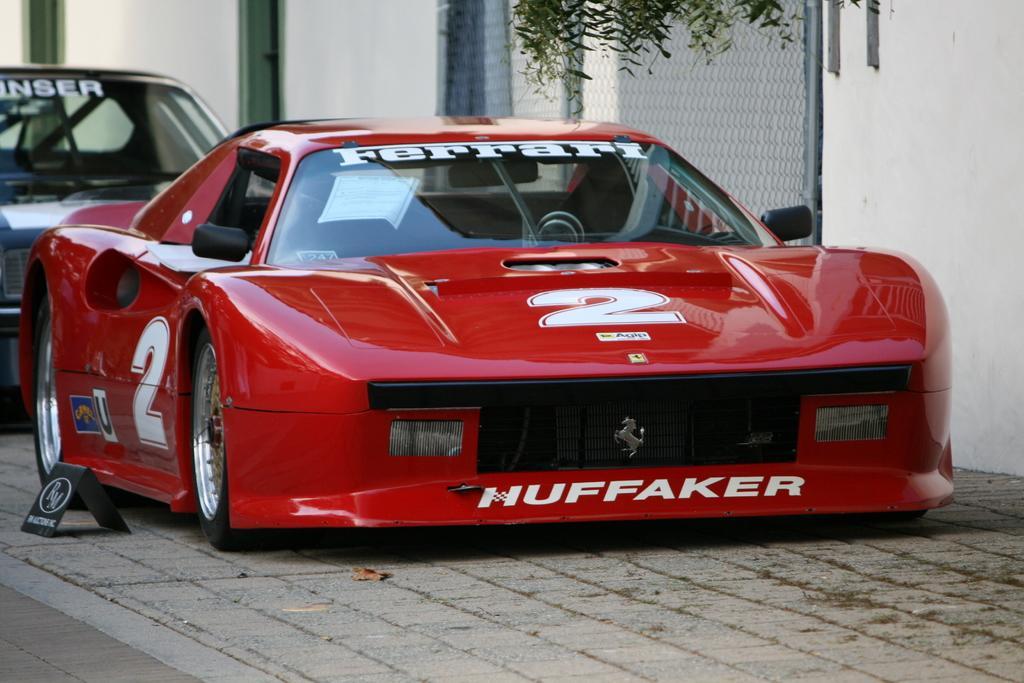Could you give a brief overview of what you see in this image? In this image we can see two cars parked on the ground. We can also see a board beside them. On the backside we can see some leaves, a metal fence, poles and a wall. 